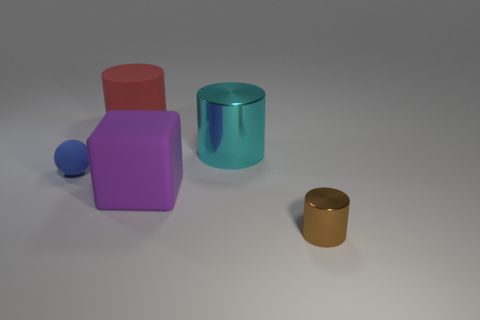Can you tell me the colors of the objects in the image? Certainly, there are four objects and their colors are as follows: one cyan cylinder, one blue sphere, one red cube, and one gold cylinder. 